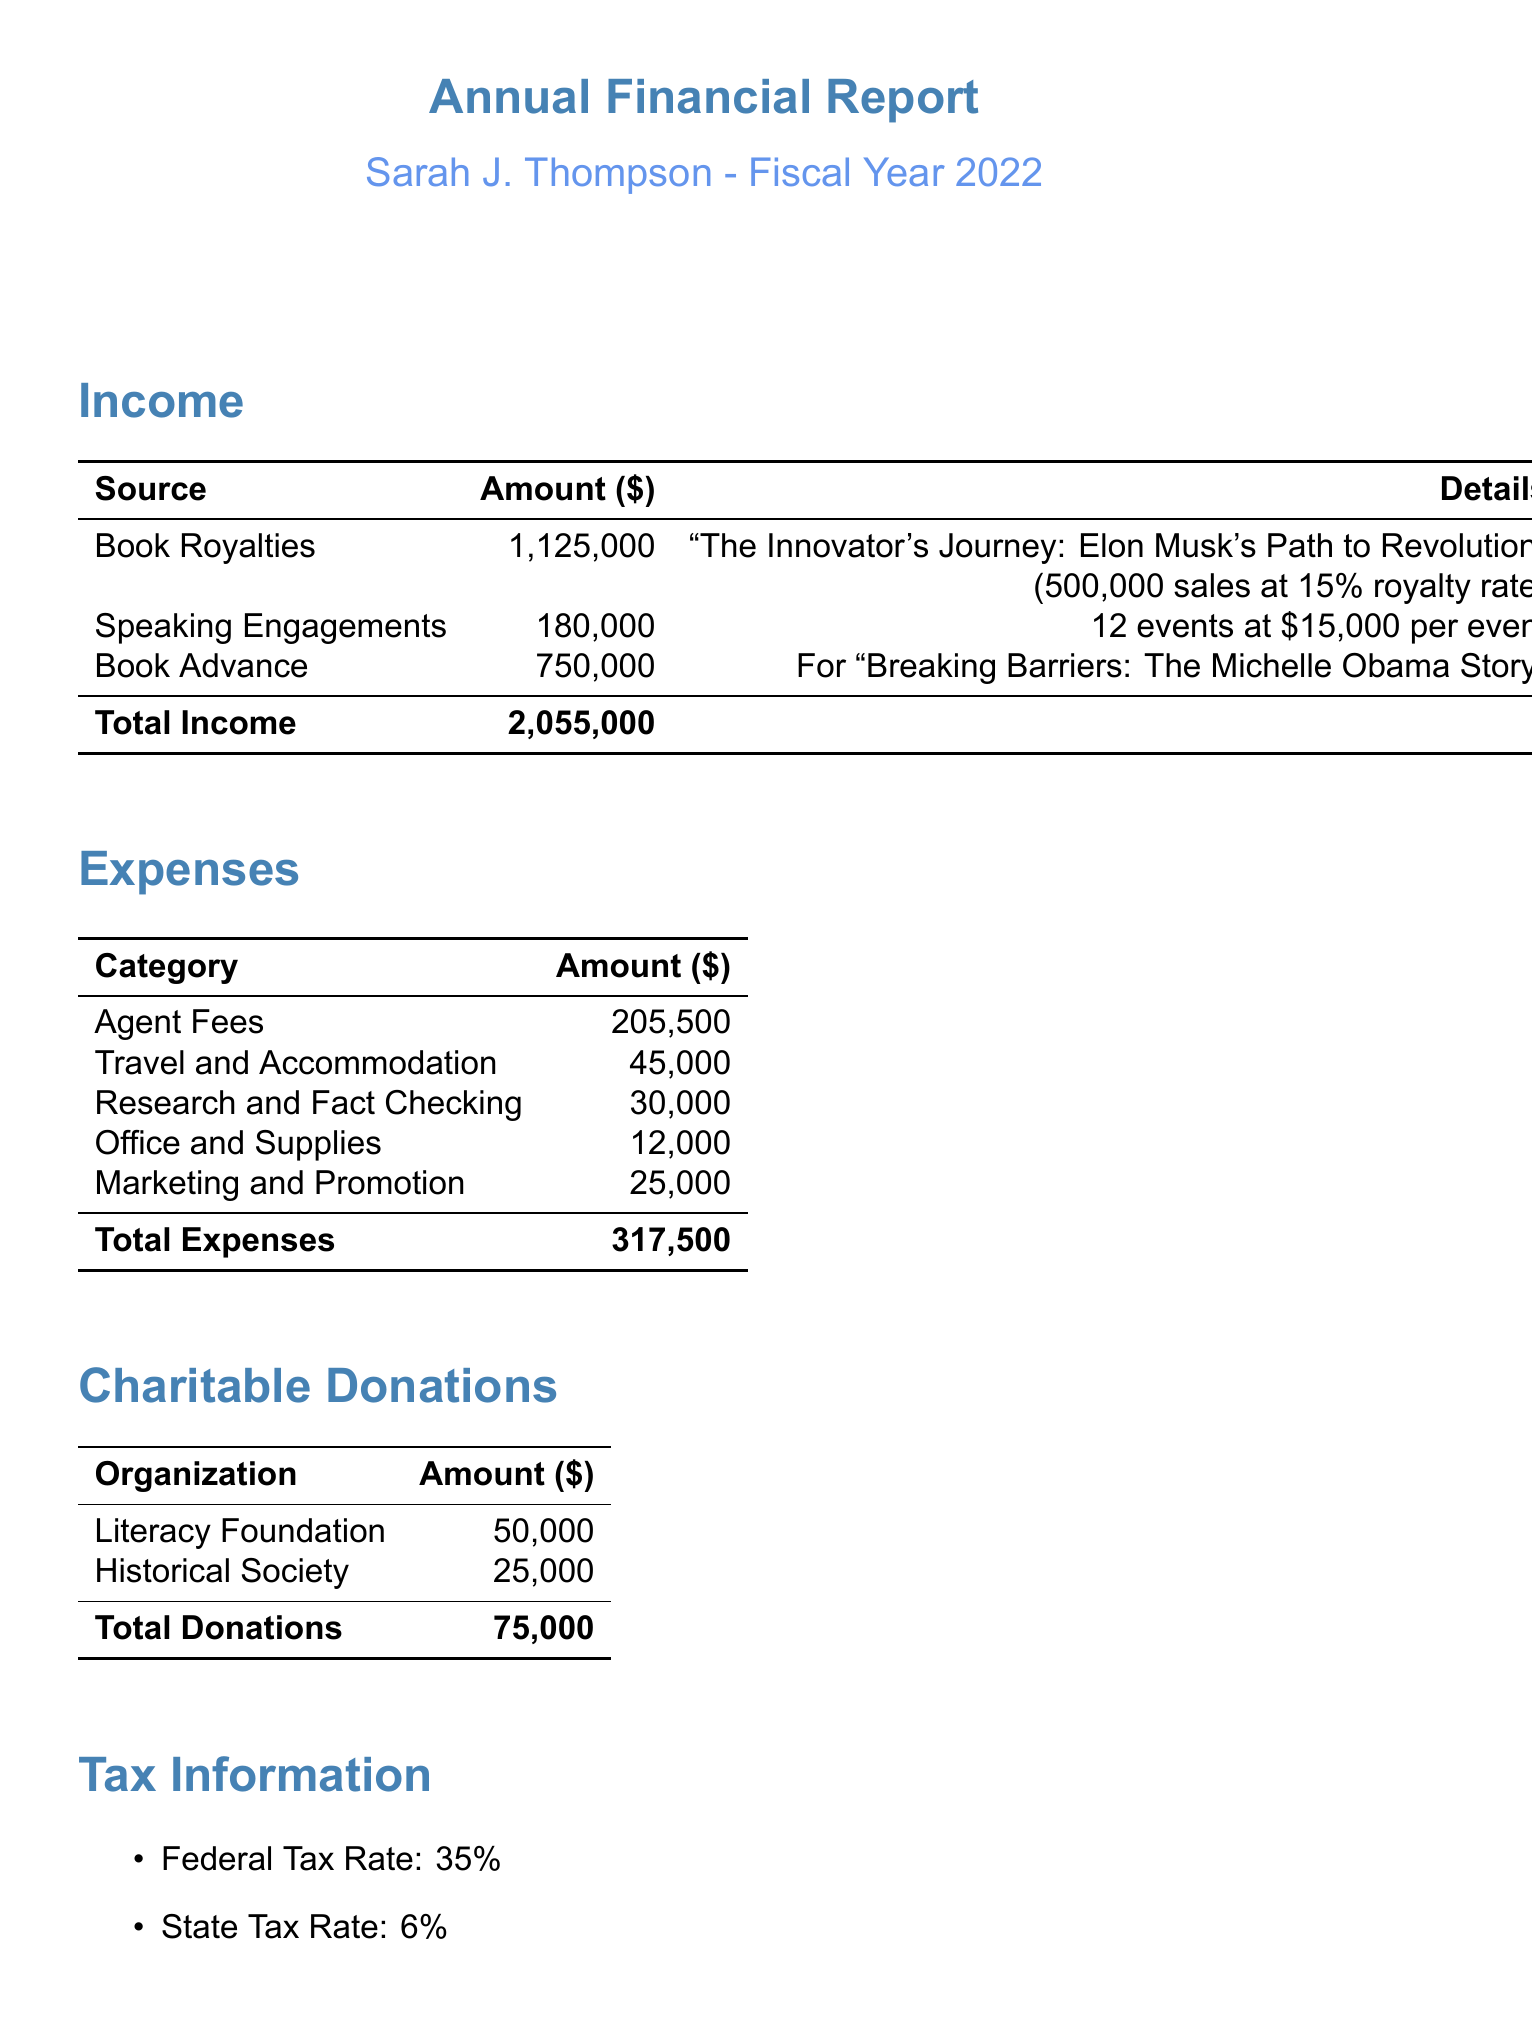what is the total book royalties? The total book royalties are listed in the document as $1,125,000.
Answer: $1,125,000 how many speaking engagements did the author have? The number of speaking engagements is stated as 12 events.
Answer: 12 what is the average fee per speaking event? The average fee per speaking event is mentioned as $15,000.
Answer: $15,000 what is the advance amount for the upcoming book? The advance amount for the upcoming book is specified as $750,000.
Answer: $750,000 what is the total amount spent on agent fees? The total amount spent on agent fees is detailed as $205,500.
Answer: $205,500 what percentage is the federal tax rate? The federal tax rate mentioned in the document is 35%.
Answer: 35% how much did the author donate to the Literacy Foundation? The amount donated to the Literacy Foundation is given as $50,000.
Answer: $50,000 what is the total income before taxes? The net income before taxes is calculated and stated as $1,662,500.
Answer: $1,662,500 what is the total for marketing and promotion expenses? The total for marketing and promotion expenses is listed as $25,000.
Answer: $25,000 what is the title of the best-selling biography? The title of the best-selling biography is “The Innovator's Journey: Elon Musk's Path to Revolution.”
Answer: “The Innovator's Journey: Elon Musk's Path to Revolution” 